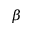Convert formula to latex. <formula><loc_0><loc_0><loc_500><loc_500>\beta</formula> 